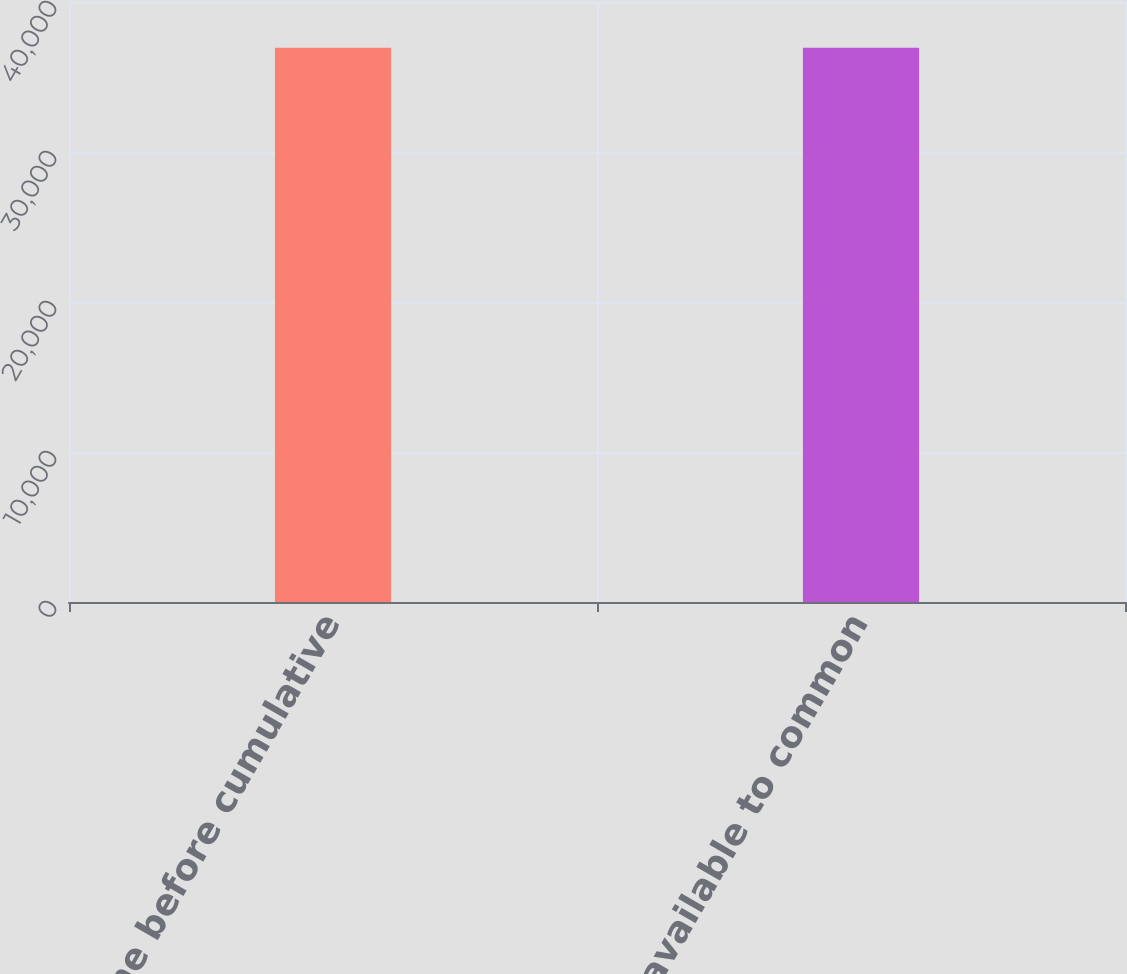<chart> <loc_0><loc_0><loc_500><loc_500><bar_chart><fcel>Income before cumulative<fcel>Net income available to common<nl><fcel>36957<fcel>36957.1<nl></chart> 